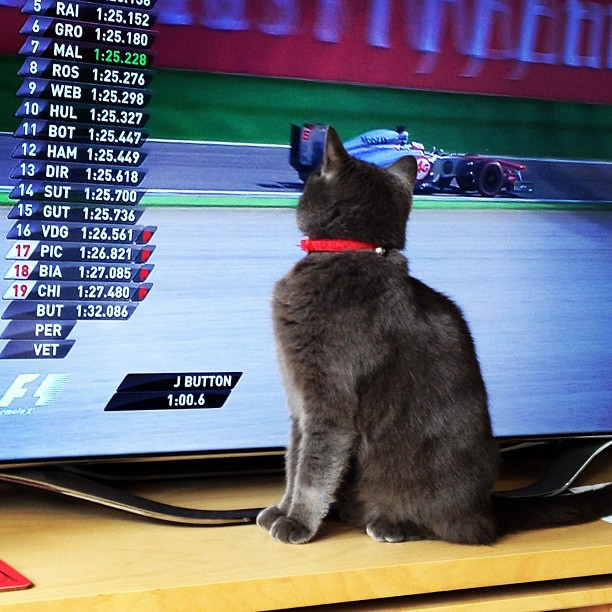Please transcribe the text information in this image. GRO MAL ROS WEB HUL 1:00.6 BUTTON J VET PER BUT CHI BIA 1:32.086 1:27.480 1:27.085 1:26.821 PIC VDG GUT SUT DIR 1:26.561 1:25.736 1:25.700 1:25.618 1:25.449 HAM BOT 1:25.447 1:25.327 1:25.298 1:25.276 1:25.228 1:25.180 1:25.152 RAI 19 18 17 16 15 14 13 12 11 10 9 8 7 6 5 